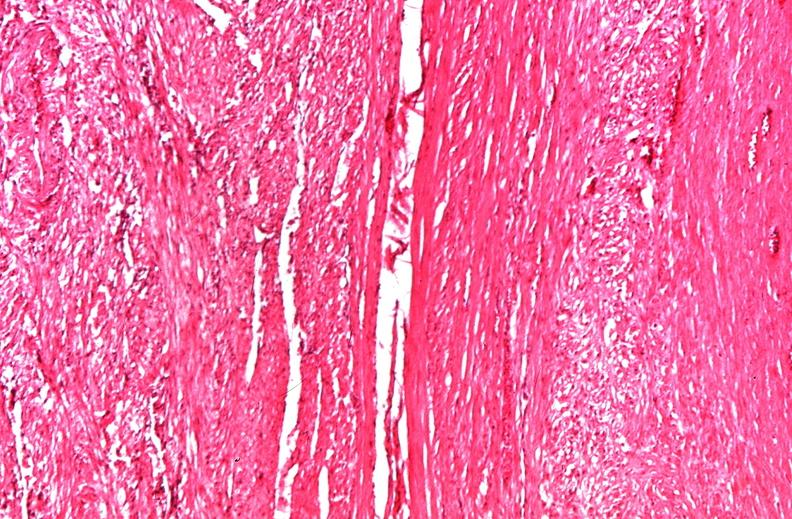what does this image show?
Answer the question using a single word or phrase. Uterus 